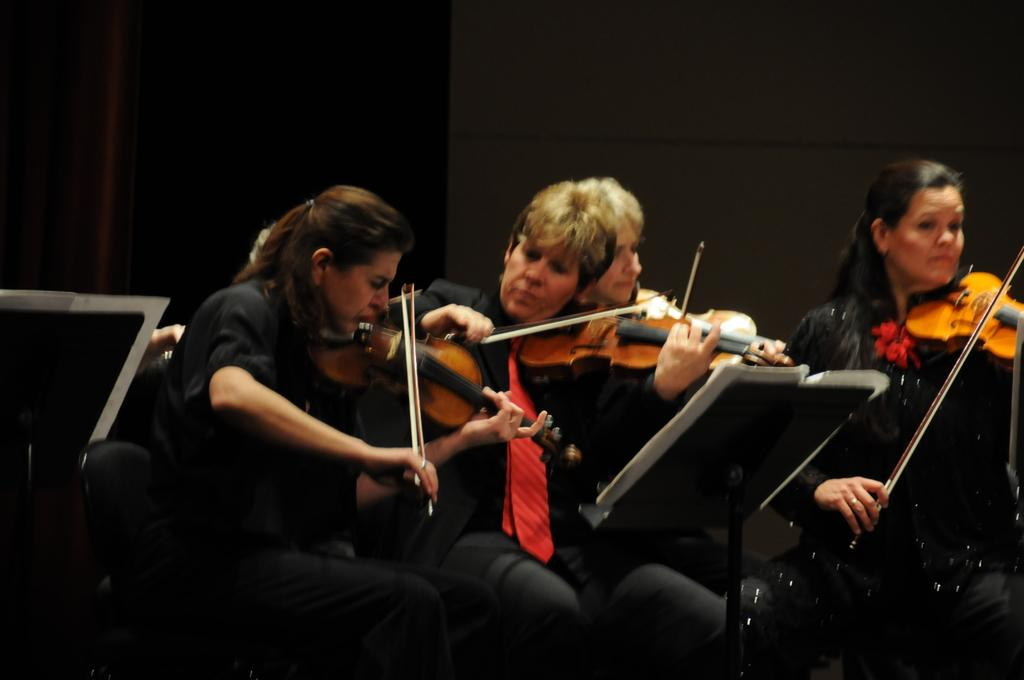What are the people in the image doing? The people in the image are playing musical instruments. What else can be seen in the image besides the people playing instruments? There are papers and black objects visible in the image. What is in the background of the image? There is a wall in the background of the image. How many umbrellas are being used by the people playing musical instruments in the image? There are no umbrellas present in the image. What type of hands are visible in the image? The image does not focus on the hands of the people playing musical instruments, so it is not possible to describe their type. 